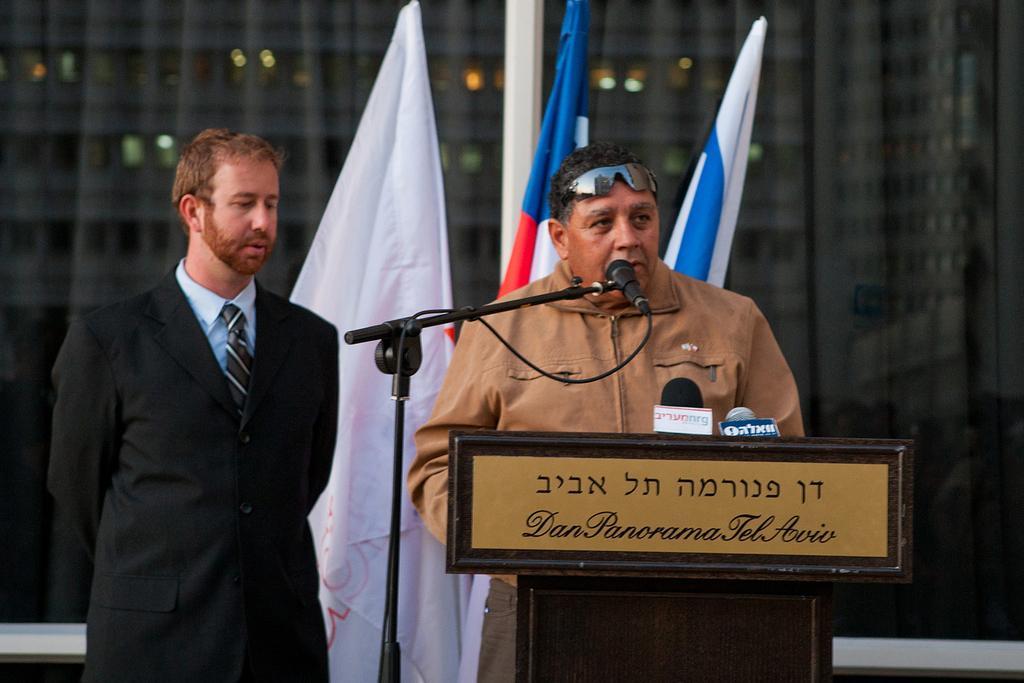Can you describe this image briefly? In this picture we can see there are two men standing. In front of the man there is a podium. On the podium there is a nameplate and microphones. On the left side of the podium there is a stand with a microphone. Behind the men there are flags, a building and an object. 